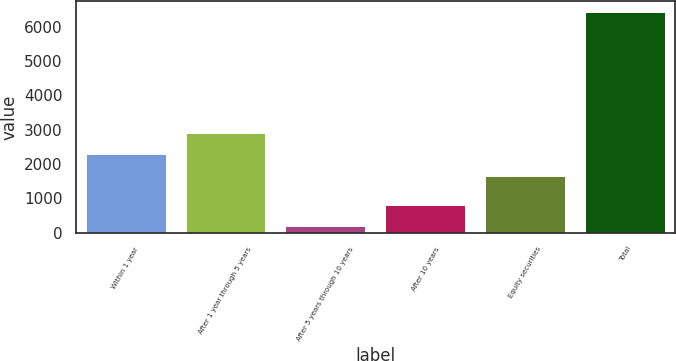<chart> <loc_0><loc_0><loc_500><loc_500><bar_chart><fcel>Within 1 year<fcel>After 1 year through 5 years<fcel>After 5 years through 10 years<fcel>After 10 years<fcel>Equity securities<fcel>Total<nl><fcel>2276.9<fcel>2898.8<fcel>194<fcel>815.9<fcel>1655<fcel>6413<nl></chart> 